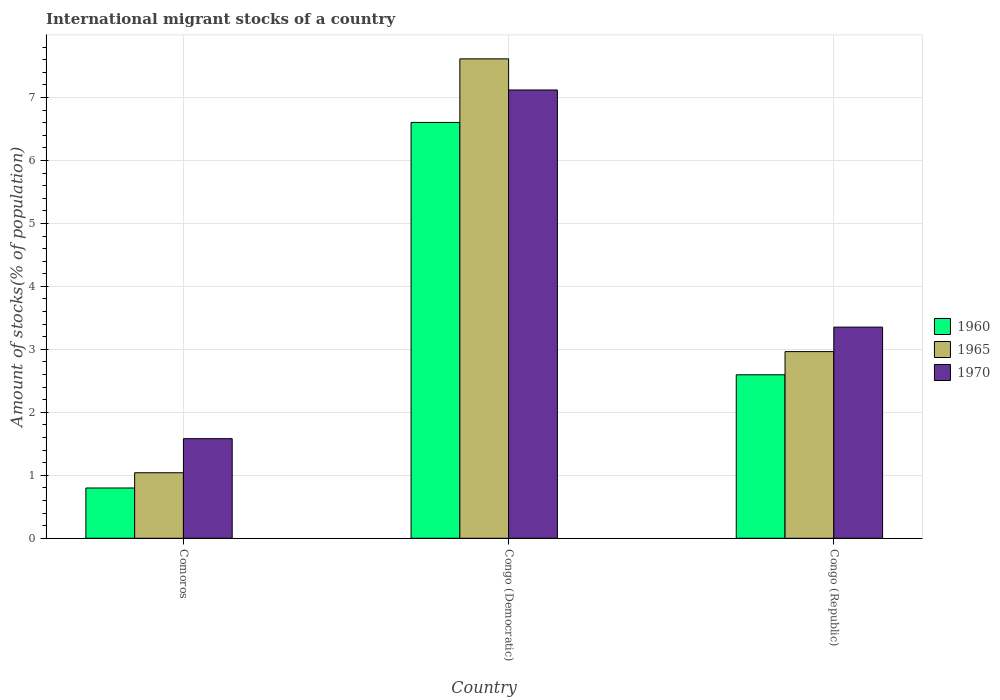How many groups of bars are there?
Keep it short and to the point. 3. Are the number of bars on each tick of the X-axis equal?
Offer a terse response. Yes. How many bars are there on the 1st tick from the left?
Give a very brief answer. 3. How many bars are there on the 3rd tick from the right?
Make the answer very short. 3. What is the label of the 2nd group of bars from the left?
Provide a succinct answer. Congo (Democratic). What is the amount of stocks in in 1970 in Congo (Republic)?
Give a very brief answer. 3.35. Across all countries, what is the maximum amount of stocks in in 1970?
Offer a very short reply. 7.12. Across all countries, what is the minimum amount of stocks in in 1965?
Your answer should be very brief. 1.04. In which country was the amount of stocks in in 1960 maximum?
Your response must be concise. Congo (Democratic). In which country was the amount of stocks in in 1965 minimum?
Offer a terse response. Comoros. What is the total amount of stocks in in 1960 in the graph?
Offer a very short reply. 10. What is the difference between the amount of stocks in in 1970 in Comoros and that in Congo (Democratic)?
Provide a succinct answer. -5.54. What is the difference between the amount of stocks in in 1970 in Congo (Republic) and the amount of stocks in in 1960 in Congo (Democratic)?
Offer a very short reply. -3.25. What is the average amount of stocks in in 1960 per country?
Give a very brief answer. 3.33. What is the difference between the amount of stocks in of/in 1970 and amount of stocks in of/in 1960 in Congo (Republic)?
Ensure brevity in your answer.  0.76. In how many countries, is the amount of stocks in in 1970 greater than 1 %?
Provide a succinct answer. 3. What is the ratio of the amount of stocks in in 1965 in Congo (Democratic) to that in Congo (Republic)?
Provide a short and direct response. 2.57. Is the difference between the amount of stocks in in 1970 in Comoros and Congo (Democratic) greater than the difference between the amount of stocks in in 1960 in Comoros and Congo (Democratic)?
Your answer should be compact. Yes. What is the difference between the highest and the second highest amount of stocks in in 1970?
Keep it short and to the point. -1.77. What is the difference between the highest and the lowest amount of stocks in in 1965?
Make the answer very short. 6.57. Is the sum of the amount of stocks in in 1965 in Comoros and Congo (Republic) greater than the maximum amount of stocks in in 1960 across all countries?
Provide a succinct answer. No. What does the 1st bar from the right in Congo (Republic) represents?
Ensure brevity in your answer.  1970. How many bars are there?
Your answer should be very brief. 9. Are all the bars in the graph horizontal?
Give a very brief answer. No. How many countries are there in the graph?
Offer a terse response. 3. What is the difference between two consecutive major ticks on the Y-axis?
Ensure brevity in your answer.  1. Are the values on the major ticks of Y-axis written in scientific E-notation?
Keep it short and to the point. No. Does the graph contain any zero values?
Your response must be concise. No. Does the graph contain grids?
Your response must be concise. Yes. How are the legend labels stacked?
Provide a succinct answer. Vertical. What is the title of the graph?
Offer a very short reply. International migrant stocks of a country. Does "1966" appear as one of the legend labels in the graph?
Provide a short and direct response. No. What is the label or title of the Y-axis?
Make the answer very short. Amount of stocks(% of population). What is the Amount of stocks(% of population) of 1960 in Comoros?
Offer a terse response. 0.8. What is the Amount of stocks(% of population) of 1965 in Comoros?
Offer a very short reply. 1.04. What is the Amount of stocks(% of population) in 1970 in Comoros?
Keep it short and to the point. 1.58. What is the Amount of stocks(% of population) of 1960 in Congo (Democratic)?
Make the answer very short. 6.6. What is the Amount of stocks(% of population) in 1965 in Congo (Democratic)?
Make the answer very short. 7.61. What is the Amount of stocks(% of population) in 1970 in Congo (Democratic)?
Your response must be concise. 7.12. What is the Amount of stocks(% of population) in 1960 in Congo (Republic)?
Provide a short and direct response. 2.6. What is the Amount of stocks(% of population) in 1965 in Congo (Republic)?
Ensure brevity in your answer.  2.96. What is the Amount of stocks(% of population) in 1970 in Congo (Republic)?
Provide a short and direct response. 3.35. Across all countries, what is the maximum Amount of stocks(% of population) in 1960?
Your answer should be very brief. 6.6. Across all countries, what is the maximum Amount of stocks(% of population) of 1965?
Offer a terse response. 7.61. Across all countries, what is the maximum Amount of stocks(% of population) of 1970?
Give a very brief answer. 7.12. Across all countries, what is the minimum Amount of stocks(% of population) of 1960?
Offer a terse response. 0.8. Across all countries, what is the minimum Amount of stocks(% of population) in 1965?
Make the answer very short. 1.04. Across all countries, what is the minimum Amount of stocks(% of population) of 1970?
Offer a very short reply. 1.58. What is the total Amount of stocks(% of population) of 1960 in the graph?
Give a very brief answer. 10. What is the total Amount of stocks(% of population) of 1965 in the graph?
Keep it short and to the point. 11.62. What is the total Amount of stocks(% of population) of 1970 in the graph?
Keep it short and to the point. 12.05. What is the difference between the Amount of stocks(% of population) in 1960 in Comoros and that in Congo (Democratic)?
Your response must be concise. -5.81. What is the difference between the Amount of stocks(% of population) in 1965 in Comoros and that in Congo (Democratic)?
Provide a succinct answer. -6.57. What is the difference between the Amount of stocks(% of population) in 1970 in Comoros and that in Congo (Democratic)?
Offer a terse response. -5.54. What is the difference between the Amount of stocks(% of population) in 1960 in Comoros and that in Congo (Republic)?
Your response must be concise. -1.8. What is the difference between the Amount of stocks(% of population) in 1965 in Comoros and that in Congo (Republic)?
Provide a short and direct response. -1.92. What is the difference between the Amount of stocks(% of population) in 1970 in Comoros and that in Congo (Republic)?
Give a very brief answer. -1.77. What is the difference between the Amount of stocks(% of population) of 1960 in Congo (Democratic) and that in Congo (Republic)?
Provide a short and direct response. 4.01. What is the difference between the Amount of stocks(% of population) in 1965 in Congo (Democratic) and that in Congo (Republic)?
Give a very brief answer. 4.65. What is the difference between the Amount of stocks(% of population) of 1970 in Congo (Democratic) and that in Congo (Republic)?
Your answer should be very brief. 3.77. What is the difference between the Amount of stocks(% of population) in 1960 in Comoros and the Amount of stocks(% of population) in 1965 in Congo (Democratic)?
Make the answer very short. -6.82. What is the difference between the Amount of stocks(% of population) of 1960 in Comoros and the Amount of stocks(% of population) of 1970 in Congo (Democratic)?
Provide a short and direct response. -6.32. What is the difference between the Amount of stocks(% of population) in 1965 in Comoros and the Amount of stocks(% of population) in 1970 in Congo (Democratic)?
Keep it short and to the point. -6.08. What is the difference between the Amount of stocks(% of population) in 1960 in Comoros and the Amount of stocks(% of population) in 1965 in Congo (Republic)?
Keep it short and to the point. -2.17. What is the difference between the Amount of stocks(% of population) of 1960 in Comoros and the Amount of stocks(% of population) of 1970 in Congo (Republic)?
Offer a very short reply. -2.55. What is the difference between the Amount of stocks(% of population) of 1965 in Comoros and the Amount of stocks(% of population) of 1970 in Congo (Republic)?
Ensure brevity in your answer.  -2.31. What is the difference between the Amount of stocks(% of population) in 1960 in Congo (Democratic) and the Amount of stocks(% of population) in 1965 in Congo (Republic)?
Provide a succinct answer. 3.64. What is the difference between the Amount of stocks(% of population) in 1960 in Congo (Democratic) and the Amount of stocks(% of population) in 1970 in Congo (Republic)?
Provide a succinct answer. 3.25. What is the difference between the Amount of stocks(% of population) in 1965 in Congo (Democratic) and the Amount of stocks(% of population) in 1970 in Congo (Republic)?
Offer a terse response. 4.26. What is the average Amount of stocks(% of population) in 1960 per country?
Offer a very short reply. 3.33. What is the average Amount of stocks(% of population) of 1965 per country?
Your answer should be compact. 3.87. What is the average Amount of stocks(% of population) of 1970 per country?
Provide a succinct answer. 4.02. What is the difference between the Amount of stocks(% of population) of 1960 and Amount of stocks(% of population) of 1965 in Comoros?
Your answer should be very brief. -0.24. What is the difference between the Amount of stocks(% of population) in 1960 and Amount of stocks(% of population) in 1970 in Comoros?
Your response must be concise. -0.78. What is the difference between the Amount of stocks(% of population) in 1965 and Amount of stocks(% of population) in 1970 in Comoros?
Make the answer very short. -0.54. What is the difference between the Amount of stocks(% of population) in 1960 and Amount of stocks(% of population) in 1965 in Congo (Democratic)?
Your answer should be very brief. -1.01. What is the difference between the Amount of stocks(% of population) of 1960 and Amount of stocks(% of population) of 1970 in Congo (Democratic)?
Offer a terse response. -0.52. What is the difference between the Amount of stocks(% of population) in 1965 and Amount of stocks(% of population) in 1970 in Congo (Democratic)?
Provide a succinct answer. 0.49. What is the difference between the Amount of stocks(% of population) in 1960 and Amount of stocks(% of population) in 1965 in Congo (Republic)?
Offer a terse response. -0.37. What is the difference between the Amount of stocks(% of population) of 1960 and Amount of stocks(% of population) of 1970 in Congo (Republic)?
Your answer should be compact. -0.76. What is the difference between the Amount of stocks(% of population) in 1965 and Amount of stocks(% of population) in 1970 in Congo (Republic)?
Your answer should be very brief. -0.39. What is the ratio of the Amount of stocks(% of population) in 1960 in Comoros to that in Congo (Democratic)?
Make the answer very short. 0.12. What is the ratio of the Amount of stocks(% of population) in 1965 in Comoros to that in Congo (Democratic)?
Provide a short and direct response. 0.14. What is the ratio of the Amount of stocks(% of population) of 1970 in Comoros to that in Congo (Democratic)?
Offer a very short reply. 0.22. What is the ratio of the Amount of stocks(% of population) of 1960 in Comoros to that in Congo (Republic)?
Keep it short and to the point. 0.31. What is the ratio of the Amount of stocks(% of population) in 1965 in Comoros to that in Congo (Republic)?
Your answer should be very brief. 0.35. What is the ratio of the Amount of stocks(% of population) of 1970 in Comoros to that in Congo (Republic)?
Offer a very short reply. 0.47. What is the ratio of the Amount of stocks(% of population) in 1960 in Congo (Democratic) to that in Congo (Republic)?
Keep it short and to the point. 2.54. What is the ratio of the Amount of stocks(% of population) in 1965 in Congo (Democratic) to that in Congo (Republic)?
Make the answer very short. 2.57. What is the ratio of the Amount of stocks(% of population) of 1970 in Congo (Democratic) to that in Congo (Republic)?
Make the answer very short. 2.12. What is the difference between the highest and the second highest Amount of stocks(% of population) of 1960?
Provide a short and direct response. 4.01. What is the difference between the highest and the second highest Amount of stocks(% of population) in 1965?
Make the answer very short. 4.65. What is the difference between the highest and the second highest Amount of stocks(% of population) of 1970?
Keep it short and to the point. 3.77. What is the difference between the highest and the lowest Amount of stocks(% of population) in 1960?
Make the answer very short. 5.81. What is the difference between the highest and the lowest Amount of stocks(% of population) in 1965?
Provide a succinct answer. 6.57. What is the difference between the highest and the lowest Amount of stocks(% of population) in 1970?
Give a very brief answer. 5.54. 